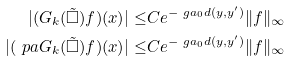Convert formula to latex. <formula><loc_0><loc_0><loc_500><loc_500>| ( G _ { k } ( \tilde { \square } ) f ) ( x ) | \leq & C e ^ { - \ g a _ { 0 } d ( y , y ^ { \prime } ) } \| f \| _ { \infty } \\ | ( \ p a G _ { k } ( \tilde { \square } ) f ) ( x ) | \leq & C e ^ { - \ g a _ { 0 } d ( y , y ^ { \prime } ) } \| f \| _ { \infty } \\</formula> 